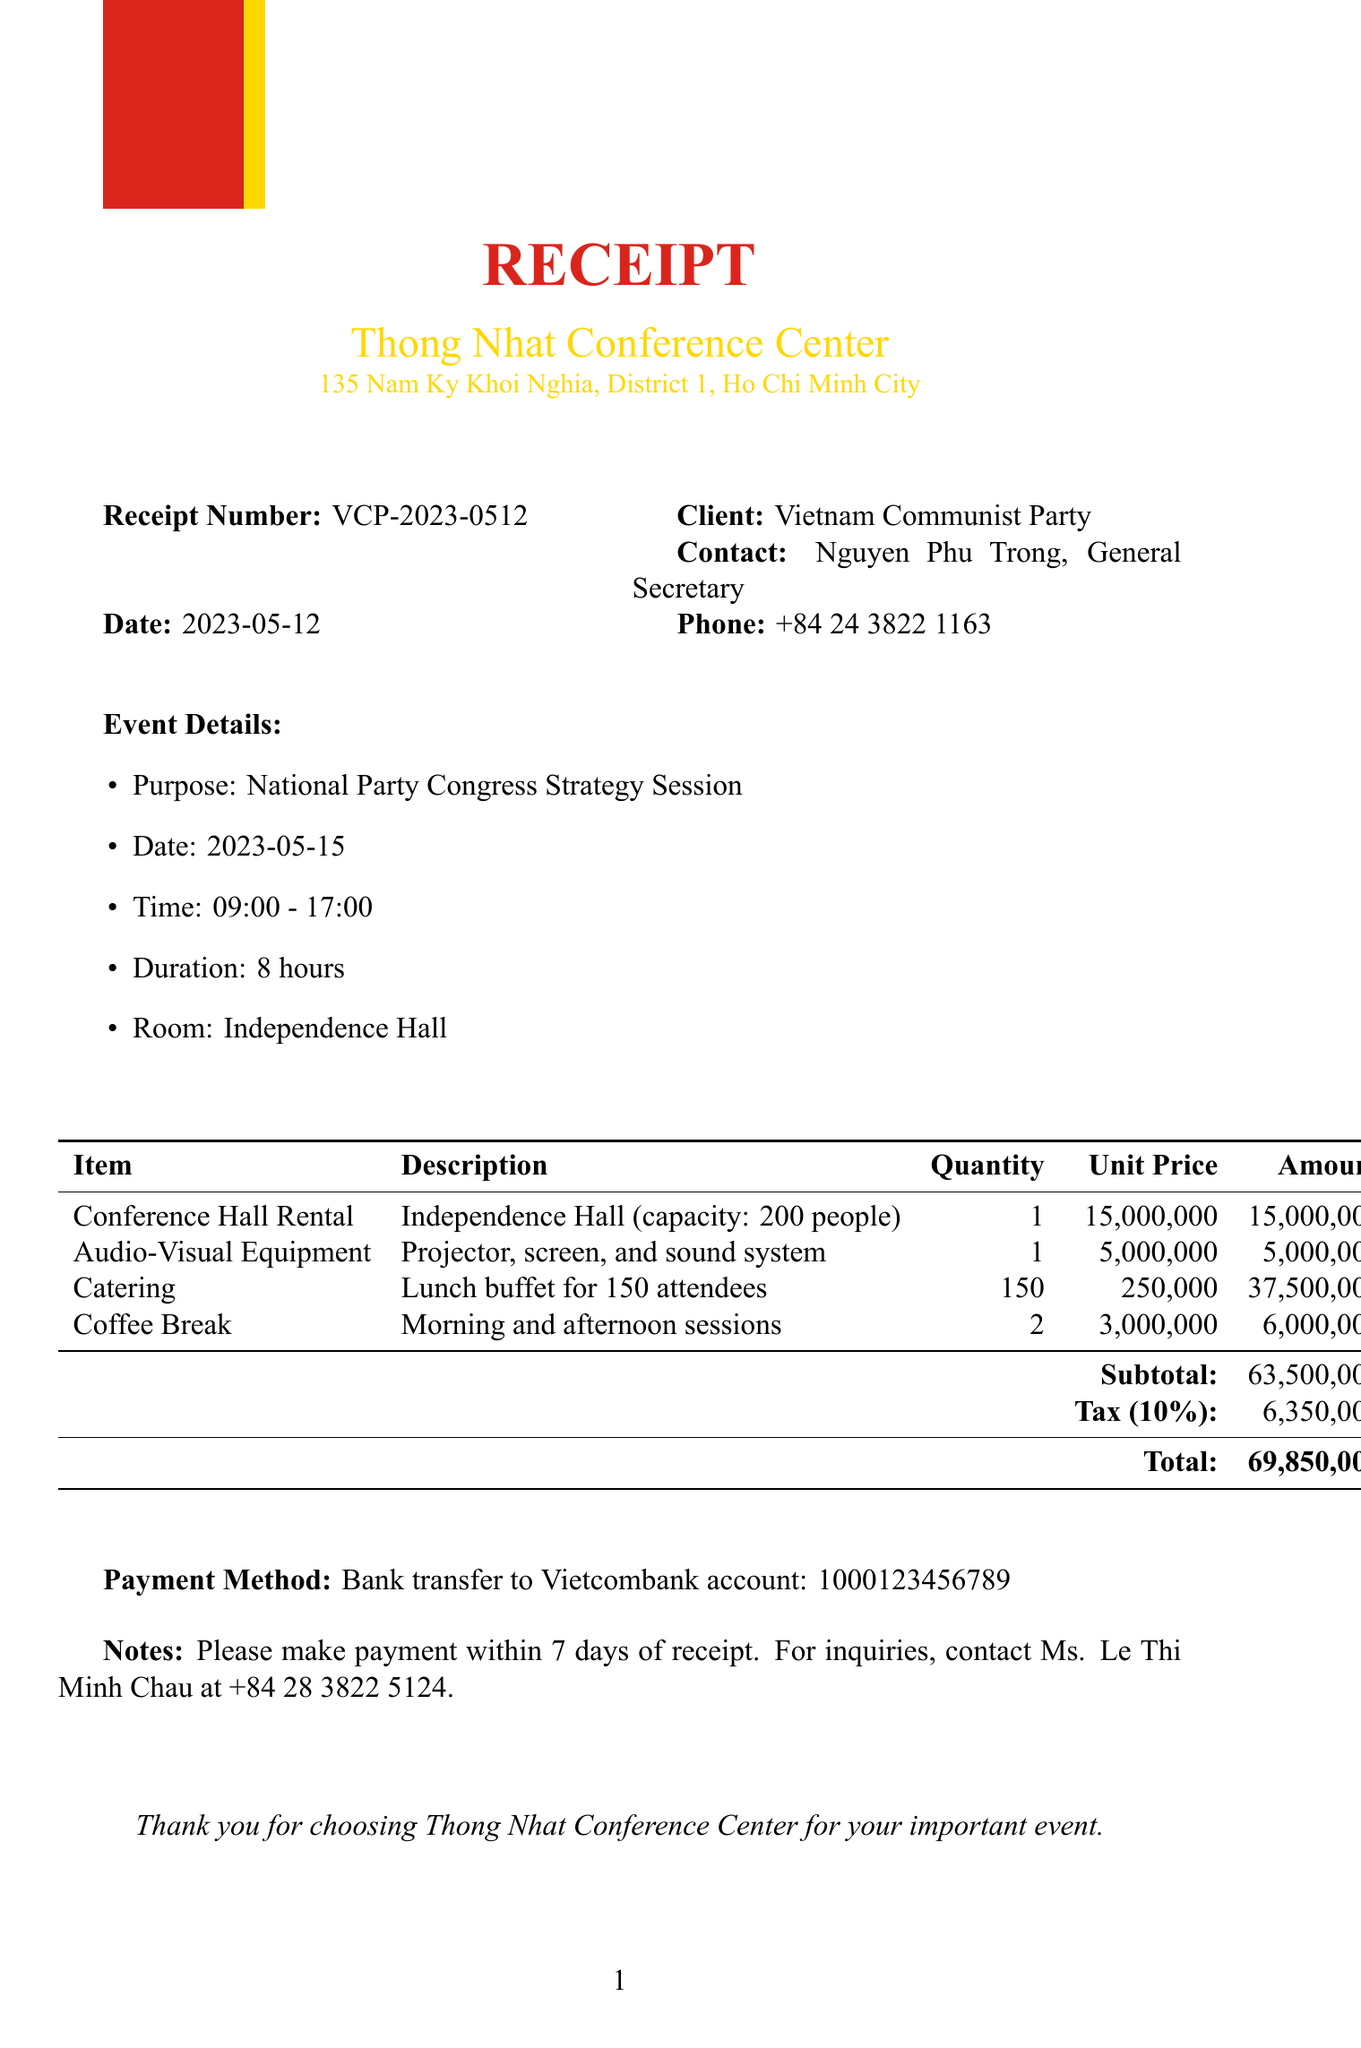What is the receipt number? The receipt number is specifically mentioned in the document as a unique identifier for this transaction.
Answer: VCP-2023-0512 What is the date of the event? The date of the event is listed under event details as the day the strategy session will take place.
Answer: 2023-05-15 Who is the contact person for the client? The contact person's name is provided in the client section of the document, representing the Vietnam Communist Party.
Answer: Nguyen Phu Trong What is the total amount due? The total amount due is found in the summary table indicating the final cost of services rendered in the receipt.
Answer: 69,850,000 How many attendees are included in the catering service? The number of attendees for whom catering is planned is explicitly stated in the services section dealing with food provisions.
Answer: 150 What room is reserved for the event? The room designated for the event is indicated clearly in the event details section of the document.
Answer: Independence Hall What is the payment method? The payment method is specified in the document, detailing how the client should settle the total amount due.
Answer: Bank transfer to Vietcombank account: 1000123456789 What is the tax rate applied? The tax rate applicable to the subtotal is provided in the tax section of the receipt.
Answer: 10% What is the purpose of the event? The purpose of the event is clearly stated in the event details section, outlining the nature of the meeting being held.
Answer: National Party Congress Strategy Session What should the client do within 7 days of receipt? Instructions are provided in the notes section, outlining a specific necessary action for the client after receiving the document.
Answer: Make payment 